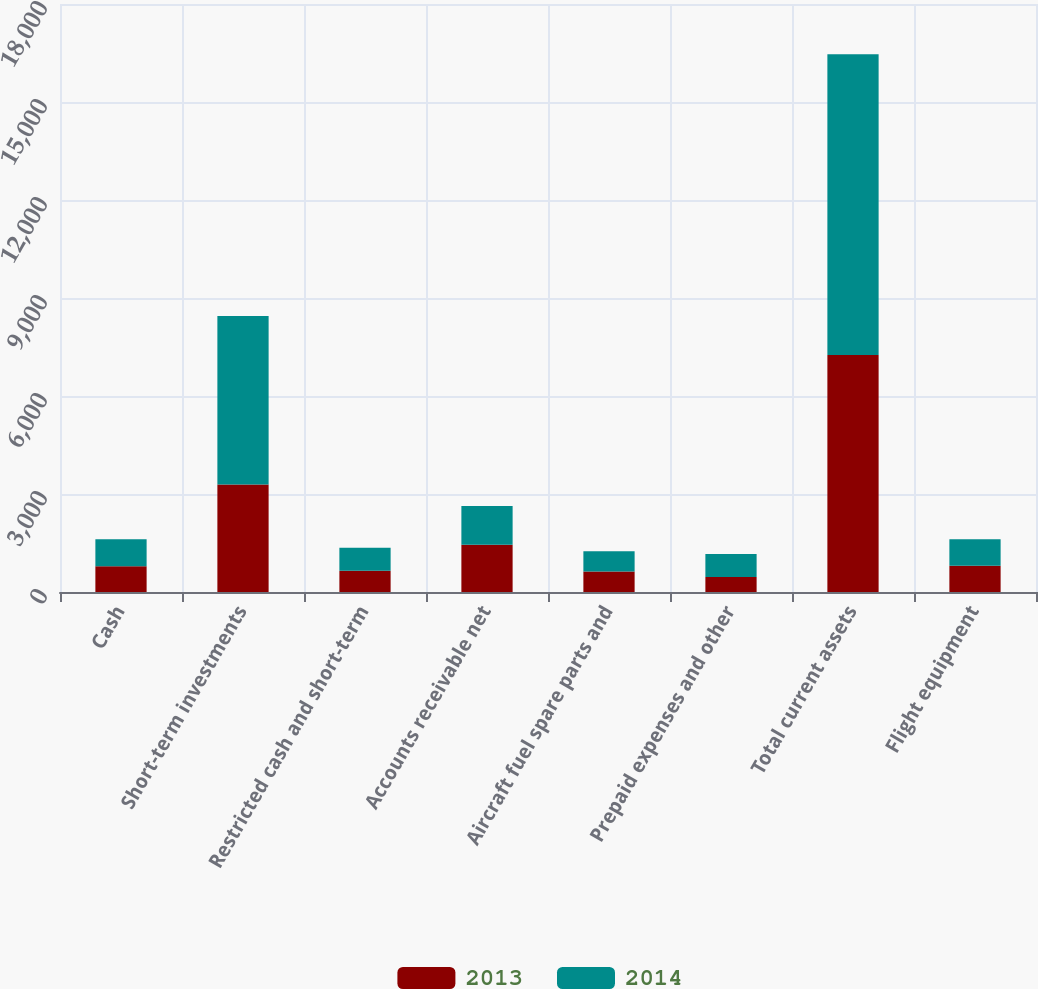<chart> <loc_0><loc_0><loc_500><loc_500><stacked_bar_chart><ecel><fcel>Cash<fcel>Short-term investments<fcel>Restricted cash and short-term<fcel>Accounts receivable net<fcel>Aircraft fuel spare parts and<fcel>Prepaid expenses and other<fcel>Total current assets<fcel>Flight equipment<nl><fcel>2013<fcel>785<fcel>3290<fcel>650<fcel>1445<fcel>625<fcel>462<fcel>7257<fcel>807<nl><fcel>2014<fcel>829<fcel>5162<fcel>702<fcel>1186<fcel>620<fcel>702<fcel>9201<fcel>807<nl></chart> 